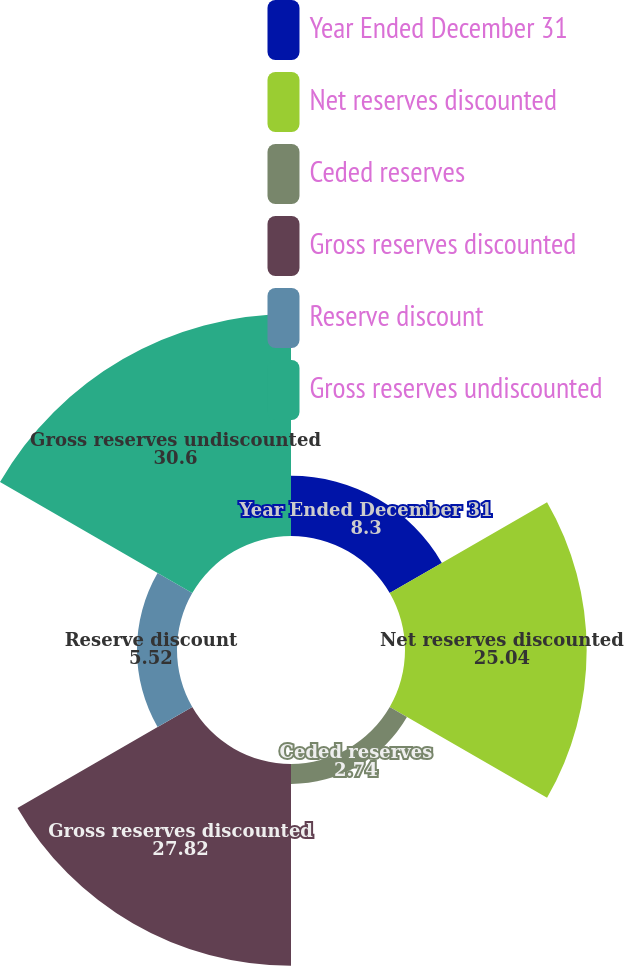Convert chart to OTSL. <chart><loc_0><loc_0><loc_500><loc_500><pie_chart><fcel>Year Ended December 31<fcel>Net reserves discounted<fcel>Ceded reserves<fcel>Gross reserves discounted<fcel>Reserve discount<fcel>Gross reserves undiscounted<nl><fcel>8.3%<fcel>25.04%<fcel>2.74%<fcel>27.82%<fcel>5.52%<fcel>30.6%<nl></chart> 